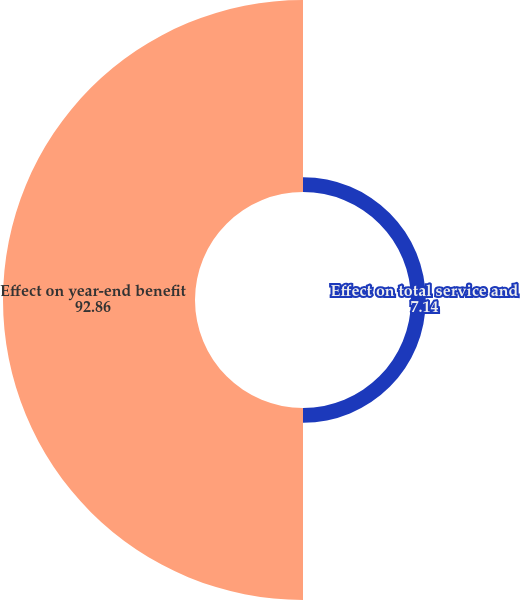Convert chart to OTSL. <chart><loc_0><loc_0><loc_500><loc_500><pie_chart><fcel>Effect on total service and<fcel>Effect on year-end benefit<nl><fcel>7.14%<fcel>92.86%<nl></chart> 